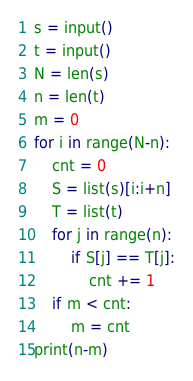<code> <loc_0><loc_0><loc_500><loc_500><_Python_>s = input()
t = input()
N = len(s)
n = len(t)
m = 0
for i in range(N-n):
    cnt = 0
    S = list(s)[i:i+n]
    T = list(t)
    for j in range(n):
        if S[j] == T[j]:
            cnt += 1
    if m < cnt:
        m = cnt
print(n-m)</code> 